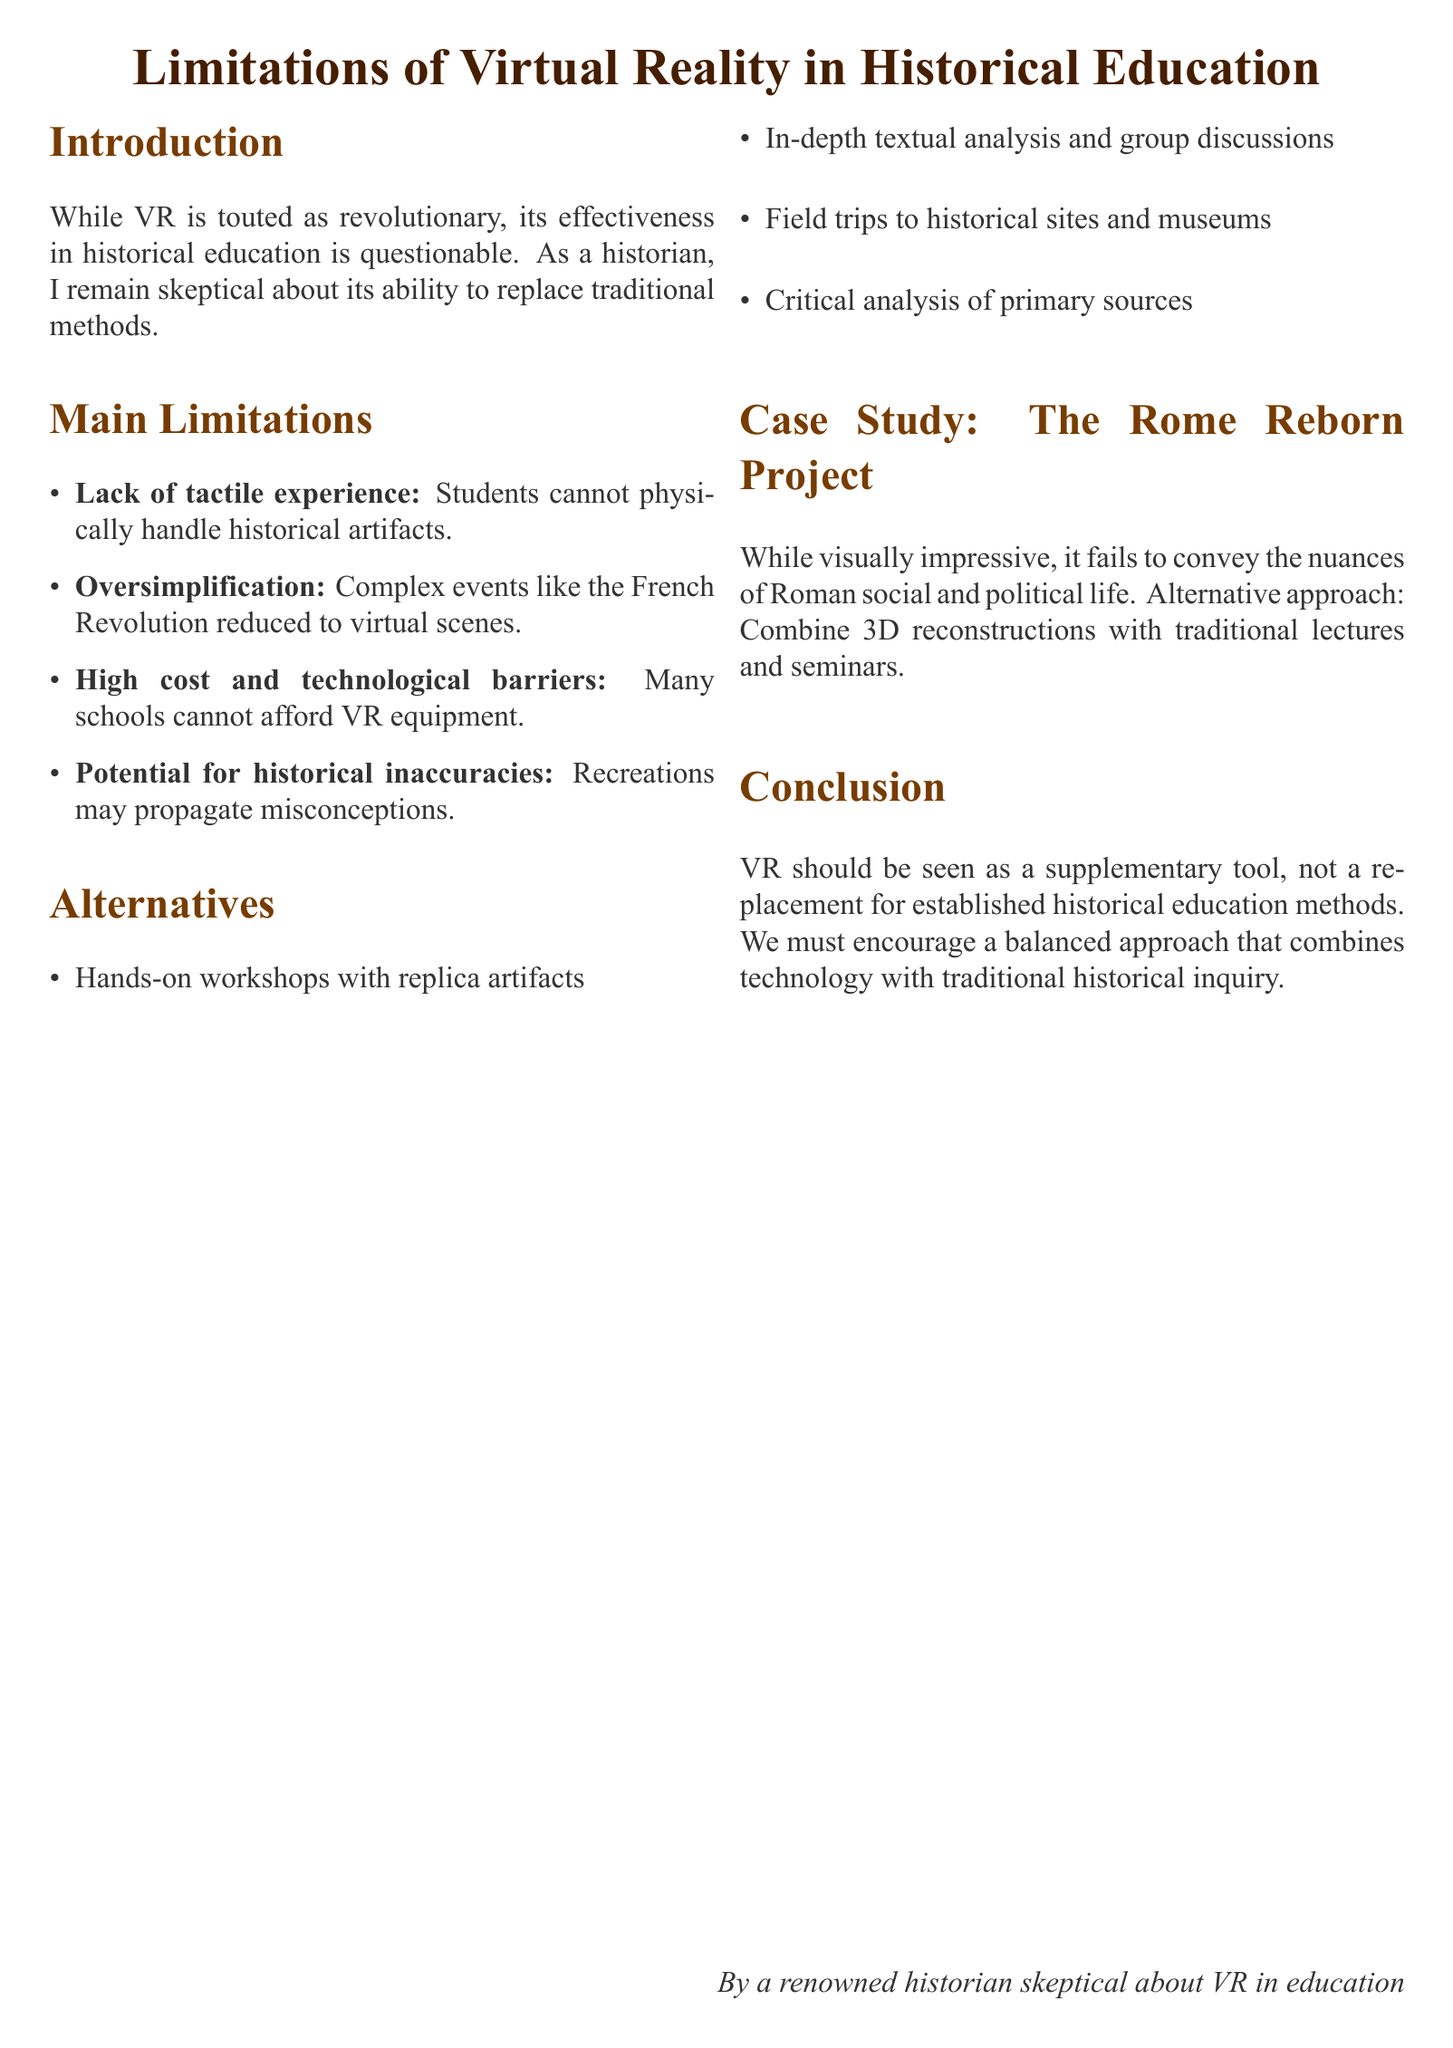What is the title of the document? The title presents the main topic of discussion regarding VR in education, which is "Limitations of Virtual Reality in Historical Education."
Answer: Limitations of Virtual Reality in Historical Education What is the personal stance of the author on VR in education? The author expresses skepticism about the capability of VR as a replacement for traditional educational methods.
Answer: Skeptical What is one limitation related to high costs? This limitation addresses the financial aspect of implementing VR, which many institutions cannot manage.
Answer: Many schools cannot afford VR equipment What is an alternative to the lack of tactile experience? The document suggests alternatives that enhance physical interaction with historical materials.
Answer: Hands-on workshops with replica artifacts What case study is mentioned in the document? The case study highlights a specific project related to the use of VR in historical education.
Answer: The Rome Reborn Project What is suggested as a critique of the Rome Reborn Project? The document evaluates the project critically, focusing on its failure to capture certain cultural aspects.
Answer: It fails to convey the nuances of Roman social and political life What should VR be considered as, according to the conclusion? The conclusion clarifies the appropriate role of VR within the educational landscape.
Answer: A supplementary tool What approach is encouraged by the author? The preferred educational method combines modern technology with established practices for optimal learning outcomes.
Answer: A balanced approach that combines technology with traditional historical inquiry 